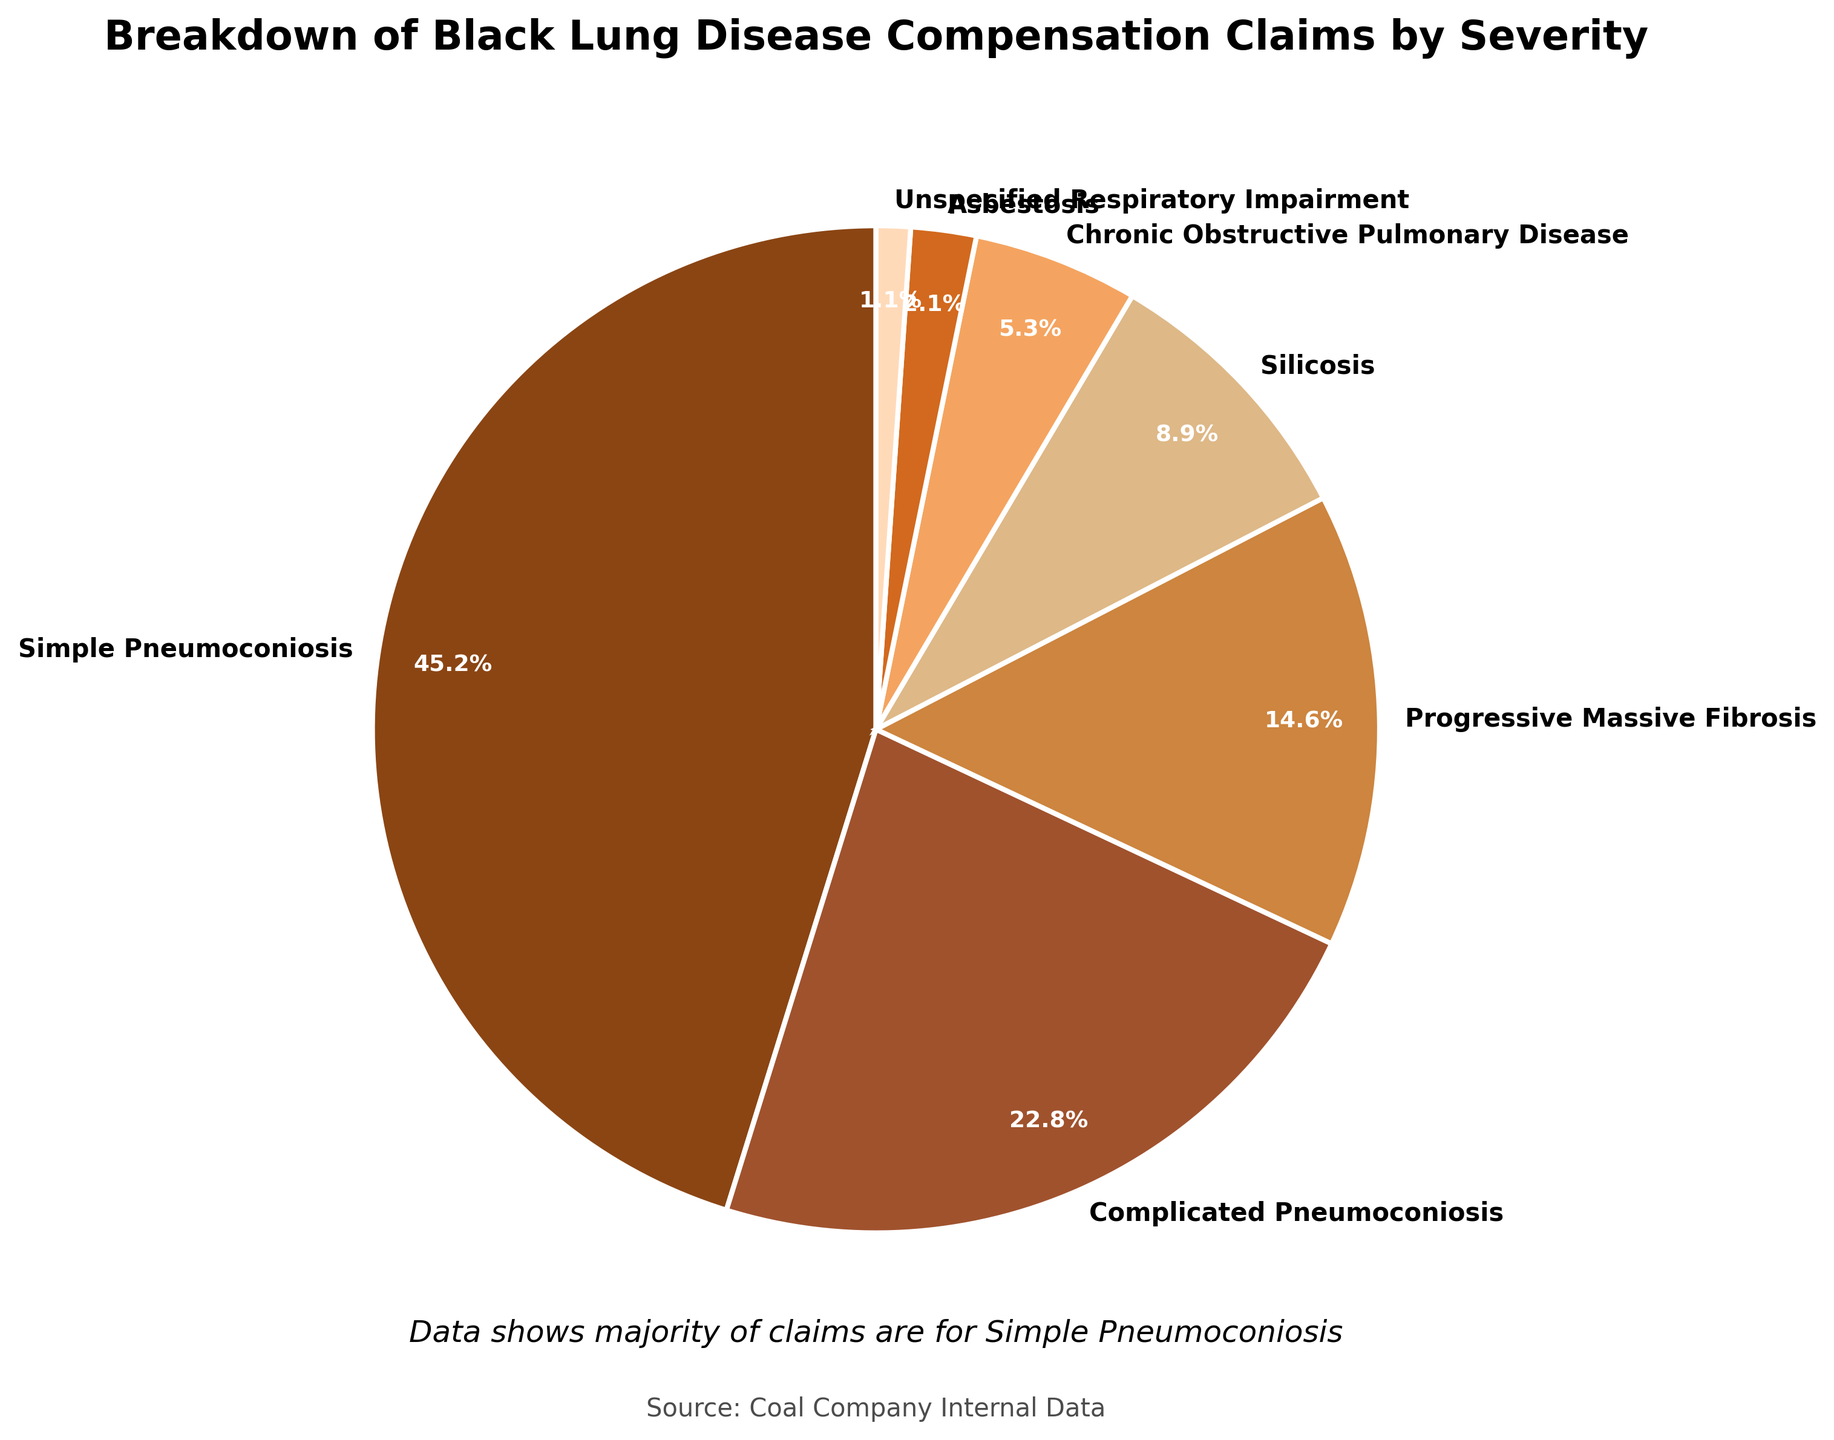Which severity of black lung disease has the highest percentage of claims? The pie chart shows the distribution of claims by severity, with Simple Pneumoconiosis taking the largest portion at 45.2%.
Answer: Simple Pneumoconiosis What is the combined percentage of claims for Complicated Pneumoconiosis and Progressive Massive Fibrosis? To find the combined percentage, add the two percentages: 22.8% + 14.6% = 37.4%.
Answer: 37.4% How does the percentage of claims for Silicosis compare to that of Chronic Obstructive Pulmonary Disease? The pie chart shows Silicosis at 8.9% and Chronic Obstructive Pulmonary Disease at 5.3%; therefore, Silicosis has a larger percentage.
Answer: Silicosis has a larger percentage What is the percentage difference between Simple Pneumoconiosis and Complicated Pneumoconiosis? Subtract Complicated Pneumoconiosis percentage from Simple Pneumoconiosis: 45.2% - 22.8% = 22.4%.
Answer: 22.4% How many categories have more than 10% of the claims? The pie chart shows only Simple Pneumoconiosis (45.2%) and Complicated Pneumoconiosis (22.8%) exceed 10%.
Answer: 2 Which category accounts for the smallest percentage of claims? The pie chart shows Unspecified Respiratory Impairment with the smallest portion at 1.1%.
Answer: Unspecified Respiratory Impairment What is the average percentage of claims across all categories? Sum the percentages (45.2 + 22.8 + 14.6 + 8.9 + 5.3 + 2.1 + 1.1 = 100) and divide by the number of categories (7): 100 / 7 ≈ 14.29%.
Answer: 14.29% Which category's claims are represented using a dark brown color? The pie chart uses a dark brown color for Simple Pneumoconiosis.
Answer: Simple Pneumoconiosis Is the percentage of claims for Asbestosis greater or lesser than 5%? The pie chart shows Asbestosis at 2.1%, which is less than 5%.
Answer: Lesser Combine the percentages of Asbestosis and Unspecified Respiratory Impairment. What fraction of the total do they make up? Add the percentages: Asbestosis (2.1%) + Unspecified Respiratory Impairment (1.1%) = 3.2%.
Answer: 3.2% 